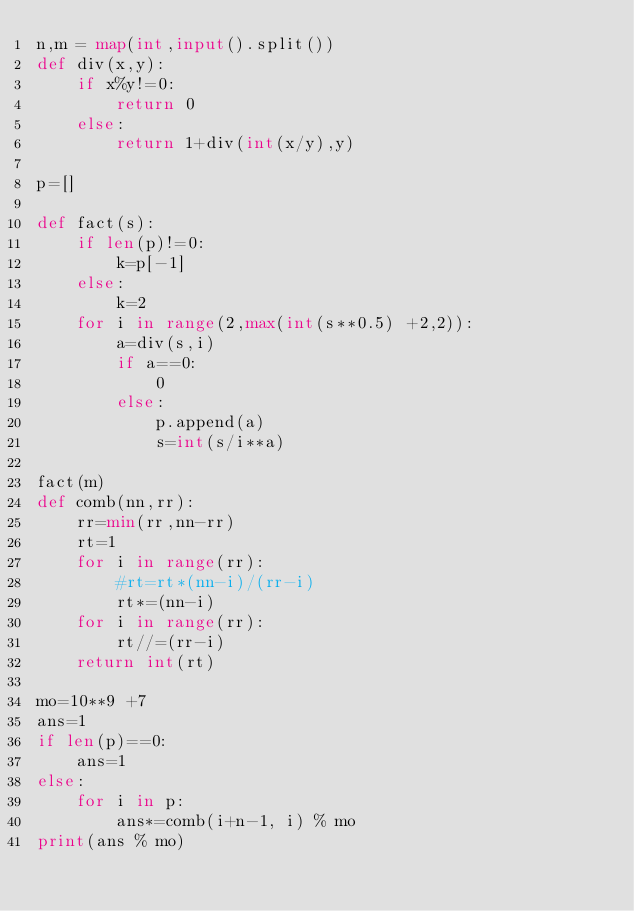Convert code to text. <code><loc_0><loc_0><loc_500><loc_500><_Python_>n,m = map(int,input().split())
def div(x,y):
    if x%y!=0:
        return 0
    else:
        return 1+div(int(x/y),y)

p=[]

def fact(s):
    if len(p)!=0:
        k=p[-1]
    else:
        k=2
    for i in range(2,max(int(s**0.5) +2,2)):
        a=div(s,i)
        if a==0:
            0
        else:
            p.append(a)
            s=int(s/i**a)
            
fact(m)
def comb(nn,rr):
    rr=min(rr,nn-rr)
    rt=1
    for i in range(rr):
        #rt=rt*(nn-i)/(rr-i)
        rt*=(nn-i)
    for i in range(rr):
        rt//=(rr-i)
    return int(rt)

mo=10**9 +7
ans=1
if len(p)==0:
    ans=1
else:
    for i in p:
        ans*=comb(i+n-1, i) % mo
print(ans % mo)</code> 